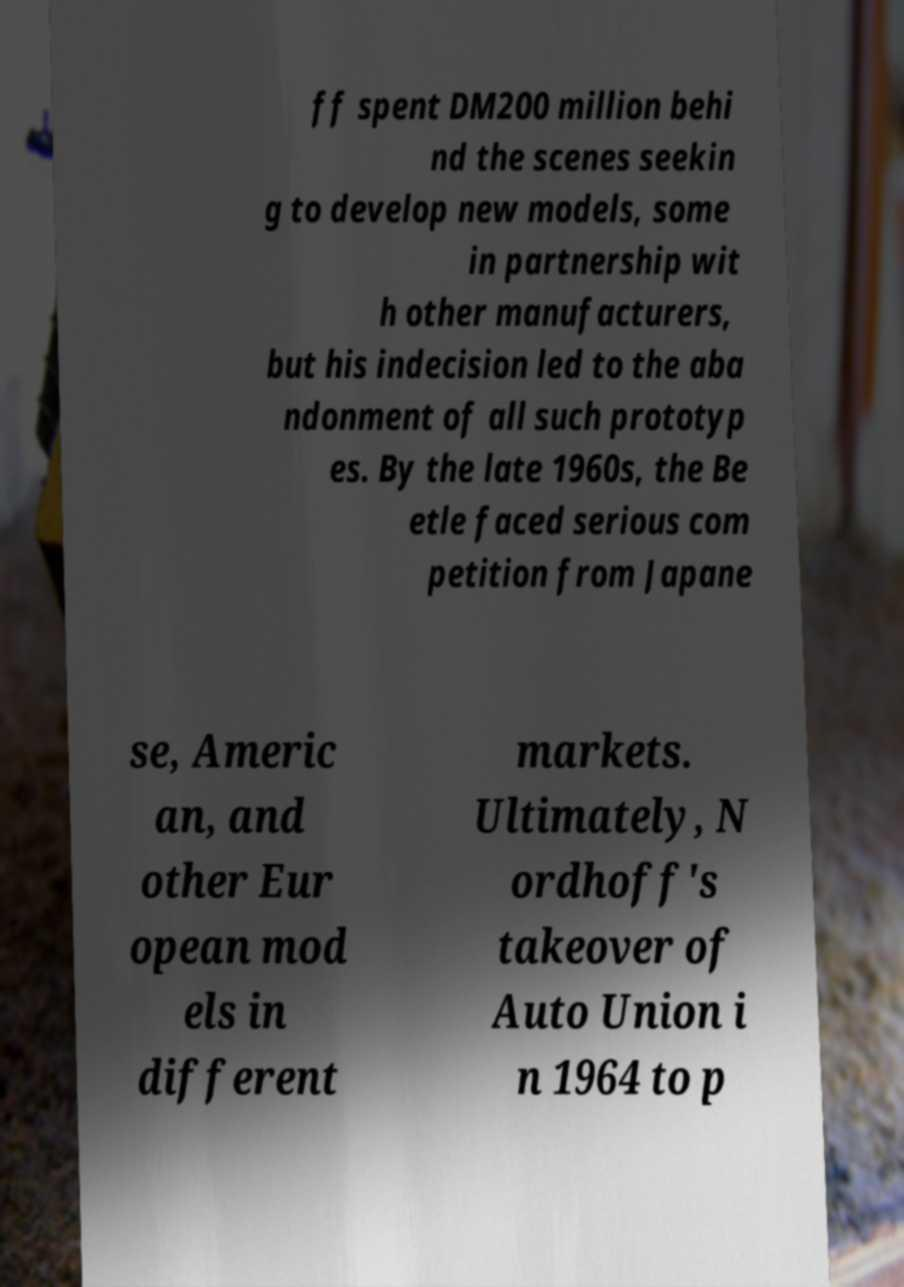Please read and relay the text visible in this image. What does it say? ff spent DM200 million behi nd the scenes seekin g to develop new models, some in partnership wit h other manufacturers, but his indecision led to the aba ndonment of all such prototyp es. By the late 1960s, the Be etle faced serious com petition from Japane se, Americ an, and other Eur opean mod els in different markets. Ultimately, N ordhoff's takeover of Auto Union i n 1964 to p 